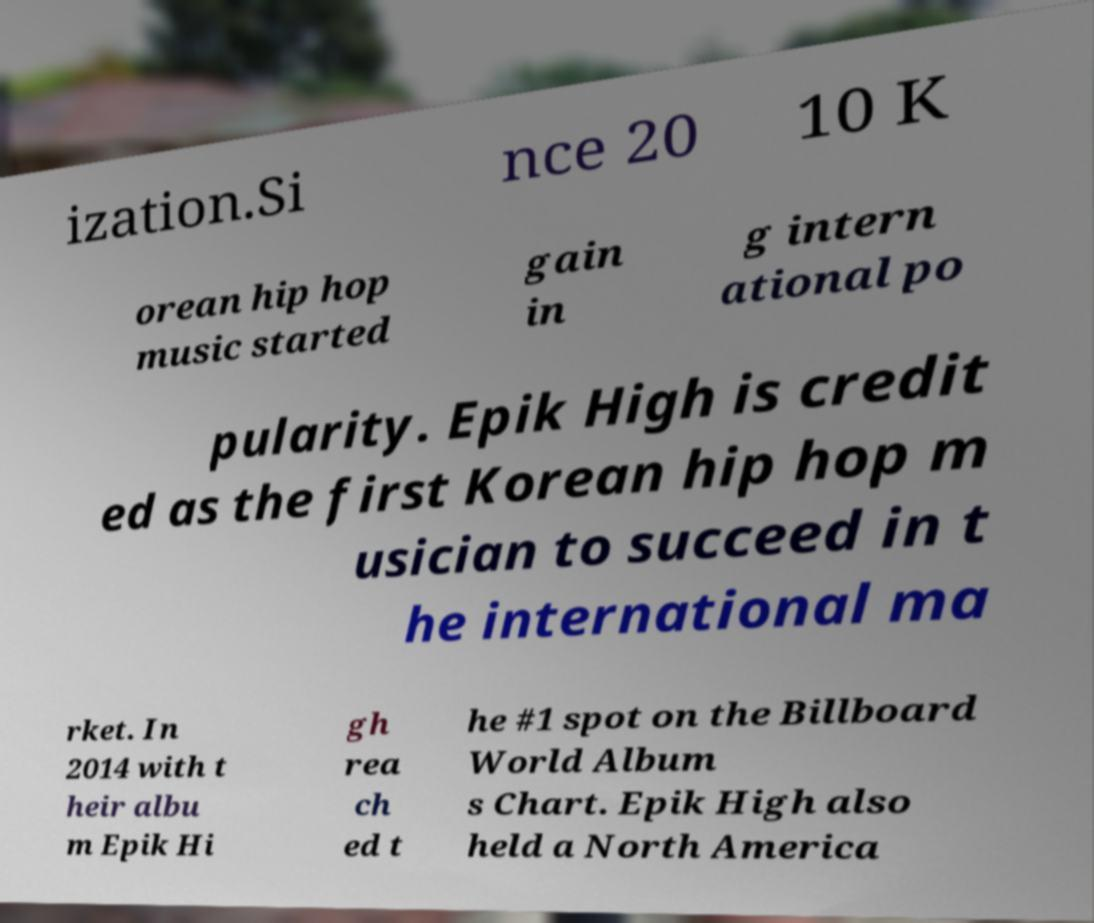Please read and relay the text visible in this image. What does it say? ization.Si nce 20 10 K orean hip hop music started gain in g intern ational po pularity. Epik High is credit ed as the first Korean hip hop m usician to succeed in t he international ma rket. In 2014 with t heir albu m Epik Hi gh rea ch ed t he #1 spot on the Billboard World Album s Chart. Epik High also held a North America 